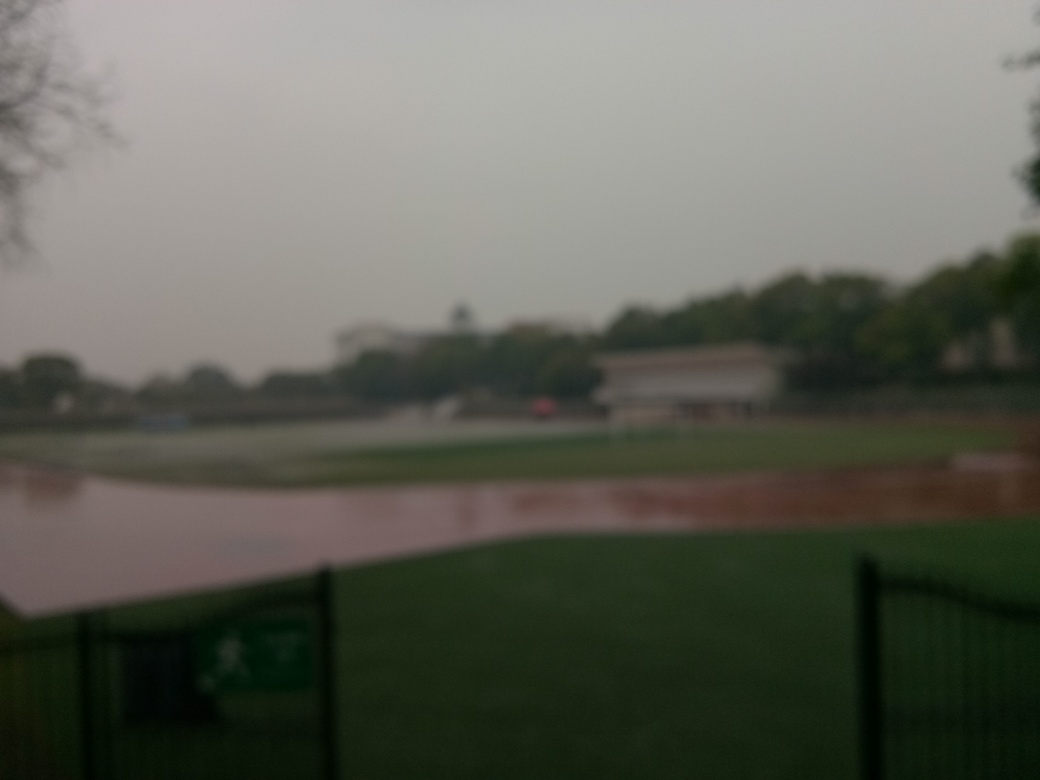Why is the quality of this image considered relatively poor?
A. High level of detail
B. Perfectly exposed
C. Due to the serious focusing issues and low overall sharpness
D. Vibrant colors
Answer with the option's letter from the given choices directly.
 C. 